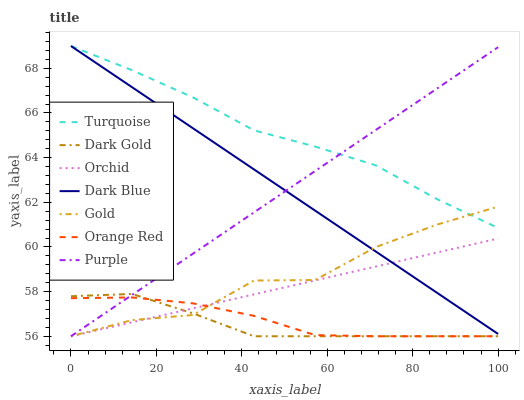Does Dark Gold have the minimum area under the curve?
Answer yes or no. Yes. Does Turquoise have the maximum area under the curve?
Answer yes or no. Yes. Does Gold have the minimum area under the curve?
Answer yes or no. No. Does Gold have the maximum area under the curve?
Answer yes or no. No. Is Purple the smoothest?
Answer yes or no. Yes. Is Gold the roughest?
Answer yes or no. Yes. Is Dark Gold the smoothest?
Answer yes or no. No. Is Dark Gold the roughest?
Answer yes or no. No. Does Gold have the lowest value?
Answer yes or no. Yes. Does Dark Blue have the lowest value?
Answer yes or no. No. Does Dark Blue have the highest value?
Answer yes or no. Yes. Does Gold have the highest value?
Answer yes or no. No. Is Dark Gold less than Dark Blue?
Answer yes or no. Yes. Is Dark Blue greater than Dark Gold?
Answer yes or no. Yes. Does Gold intersect Turquoise?
Answer yes or no. Yes. Is Gold less than Turquoise?
Answer yes or no. No. Is Gold greater than Turquoise?
Answer yes or no. No. Does Dark Gold intersect Dark Blue?
Answer yes or no. No. 